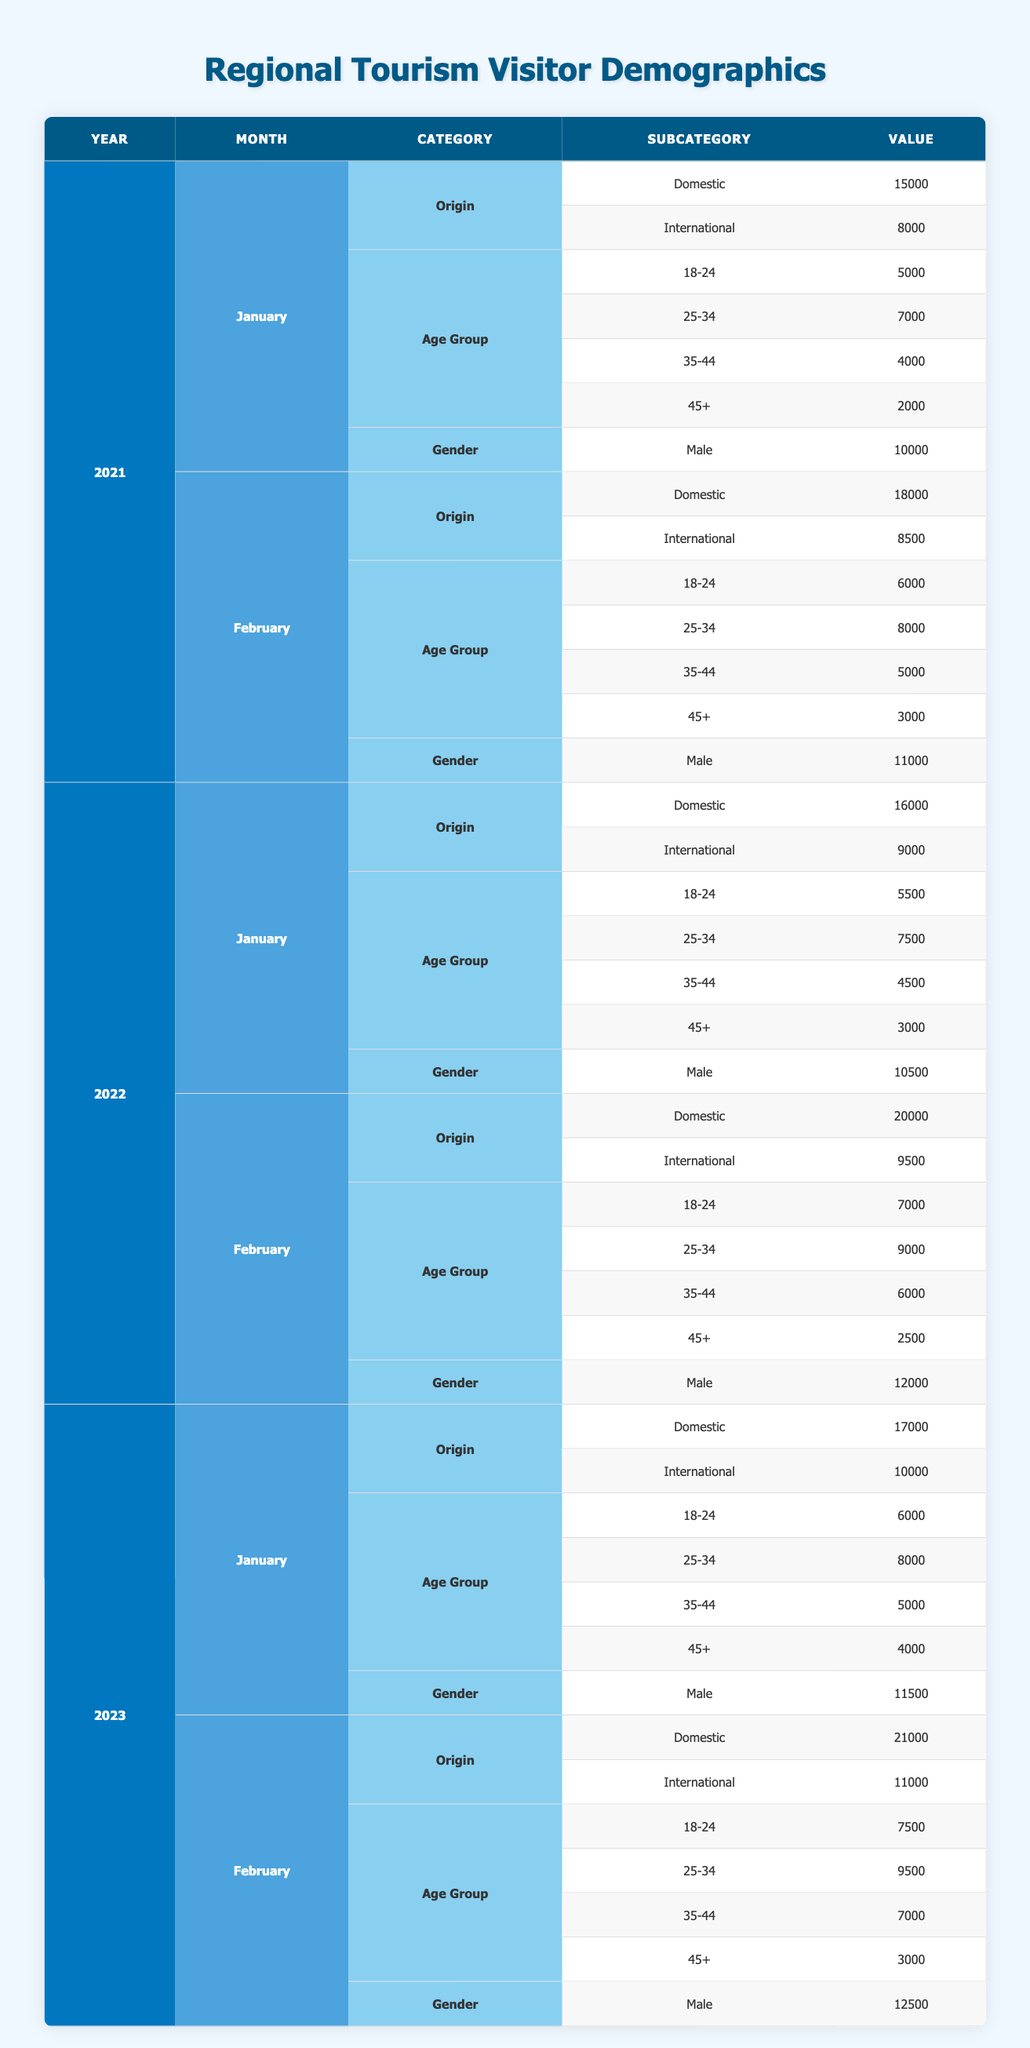What was the total number of domestic visitors in February 2022? The table shows that in February 2022, there were 20,000 domestic visitors. There is no need for calculations or further steps as the answer is directly found in the data.
Answer: 20000 How many international visitors did we have in January 2021 compared to January 2023? In January 2021, there were 8,000 international visitors. In January 2023, this number increased to 10,000. Comparing these two values shows the growth of 2,000 international visitors from 2021 to 2023.
Answer: 2000 What is the age group with the highest number of visitors in February 2023? In February 2023, the age group 25-34 had the highest number of visitors with 9,500. This is determined by reviewing the "Age Group" data for February 2023 and identifying the largest value.
Answer: 25-34 What was the gender ratio of visitors in January 2022? In January 2022, there were 10,500 male visitors and 8,500 female visitors. To find the ratio, we compare these two values. The ratio of males to females is 10,500:8,500, which simplifies to 21:17.
Answer: 21:17 Did the total number of domestic visitors increase every year from 2021 to 2023? Looking at the domestic visitor totals for January and February across the three years: January 2021 had 15,000, January 2022 had 16,000, and January 2023 had 17,000. Similarly, February figures show increases as well from 18,000 in 2021 to 20,000 in 2022 and 21,000 in 2023. Therefore, the total increased each year.
Answer: Yes What is the average number of international visitors in January across 2021, 2022, and 2023? The international visitors for January in each year were: 8,000 (2021), 9,000 (2022), and 10,000 (2023). To find the average: (8,000 + 9,000 + 10,000) / 3 = 27,000 / 3 = 9,000.
Answer: 9000 Which month in 2022 had the highest total number of visitors, and what was that total? In February 2022, combining both domestic (20,000) and international visitors (9,500), the total number of visitors was 29,500. A comparison with January 2022 (25,000) shows that February had the highest visitor count.
Answer: February 2022, 29500 What was the increase in male visitors from January 2021 to February 2023? January 2021 had 10,000 male visitors, whereas February 2023 had 12,500. The increase can be calculated as 12,500 - 10,000 = 2,500 male visitors from January 2021 to February 2023.
Answer: 2500 What proportion of visitors in February 2021 were international? In February 2021, the total number of visitors was 18,000 (Domestic) + 8,500 (International) = 26,500. The proportion of international visitors is 8,500 / 26,500 = about 0.32 or 32%.
Answer: 32% 